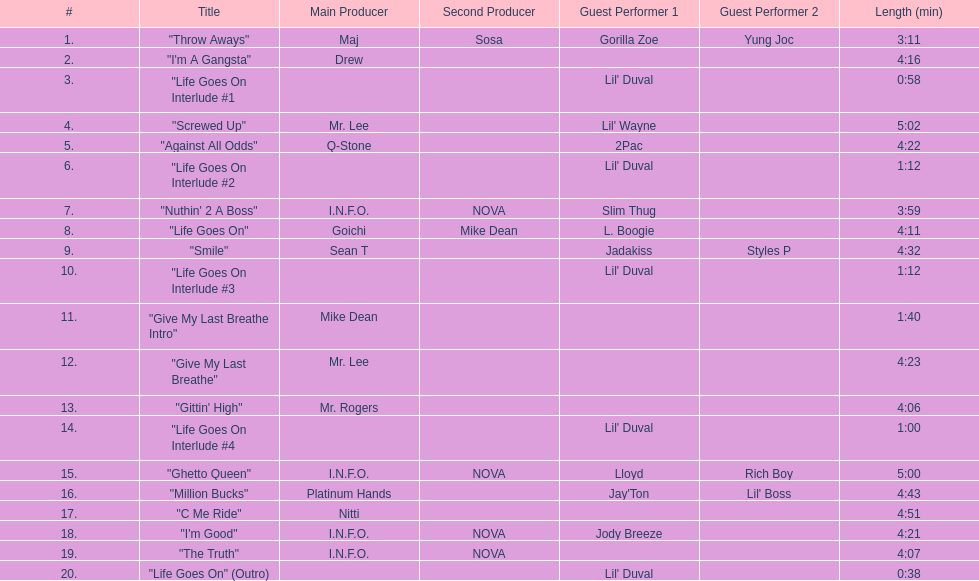How long is the longest track on the album? 5:02. 